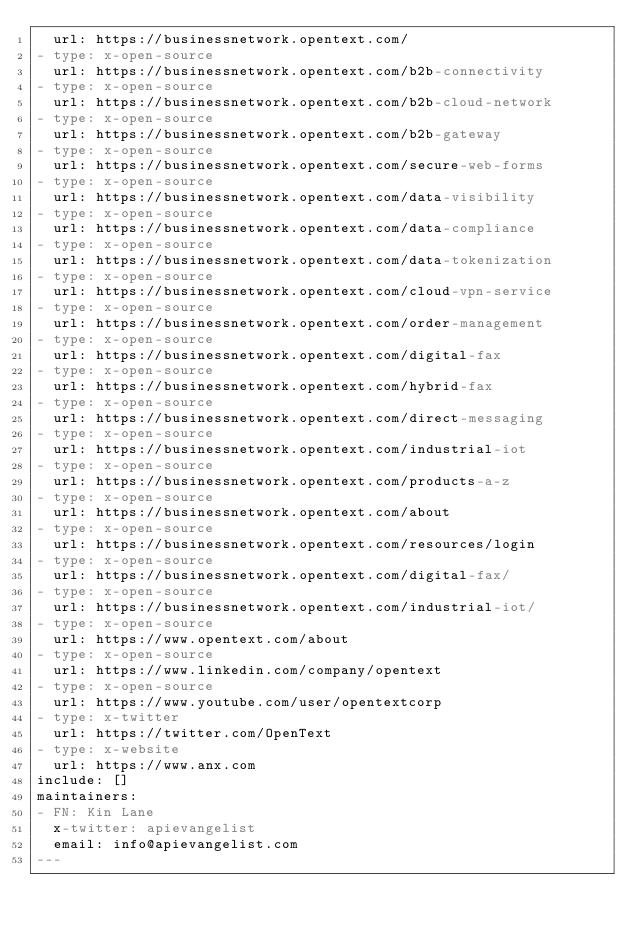Convert code to text. <code><loc_0><loc_0><loc_500><loc_500><_YAML_>  url: https://businessnetwork.opentext.com/
- type: x-open-source
  url: https://businessnetwork.opentext.com/b2b-connectivity
- type: x-open-source
  url: https://businessnetwork.opentext.com/b2b-cloud-network
- type: x-open-source
  url: https://businessnetwork.opentext.com/b2b-gateway
- type: x-open-source
  url: https://businessnetwork.opentext.com/secure-web-forms
- type: x-open-source
  url: https://businessnetwork.opentext.com/data-visibility
- type: x-open-source
  url: https://businessnetwork.opentext.com/data-compliance
- type: x-open-source
  url: https://businessnetwork.opentext.com/data-tokenization
- type: x-open-source
  url: https://businessnetwork.opentext.com/cloud-vpn-service
- type: x-open-source
  url: https://businessnetwork.opentext.com/order-management
- type: x-open-source
  url: https://businessnetwork.opentext.com/digital-fax
- type: x-open-source
  url: https://businessnetwork.opentext.com/hybrid-fax
- type: x-open-source
  url: https://businessnetwork.opentext.com/direct-messaging
- type: x-open-source
  url: https://businessnetwork.opentext.com/industrial-iot
- type: x-open-source
  url: https://businessnetwork.opentext.com/products-a-z
- type: x-open-source
  url: https://businessnetwork.opentext.com/about
- type: x-open-source
  url: https://businessnetwork.opentext.com/resources/login
- type: x-open-source
  url: https://businessnetwork.opentext.com/digital-fax/
- type: x-open-source
  url: https://businessnetwork.opentext.com/industrial-iot/
- type: x-open-source
  url: https://www.opentext.com/about
- type: x-open-source
  url: https://www.linkedin.com/company/opentext
- type: x-open-source
  url: https://www.youtube.com/user/opentextcorp
- type: x-twitter
  url: https://twitter.com/OpenText
- type: x-website
  url: https://www.anx.com
include: []
maintainers:
- FN: Kin Lane
  x-twitter: apievangelist
  email: info@apievangelist.com
---</code> 